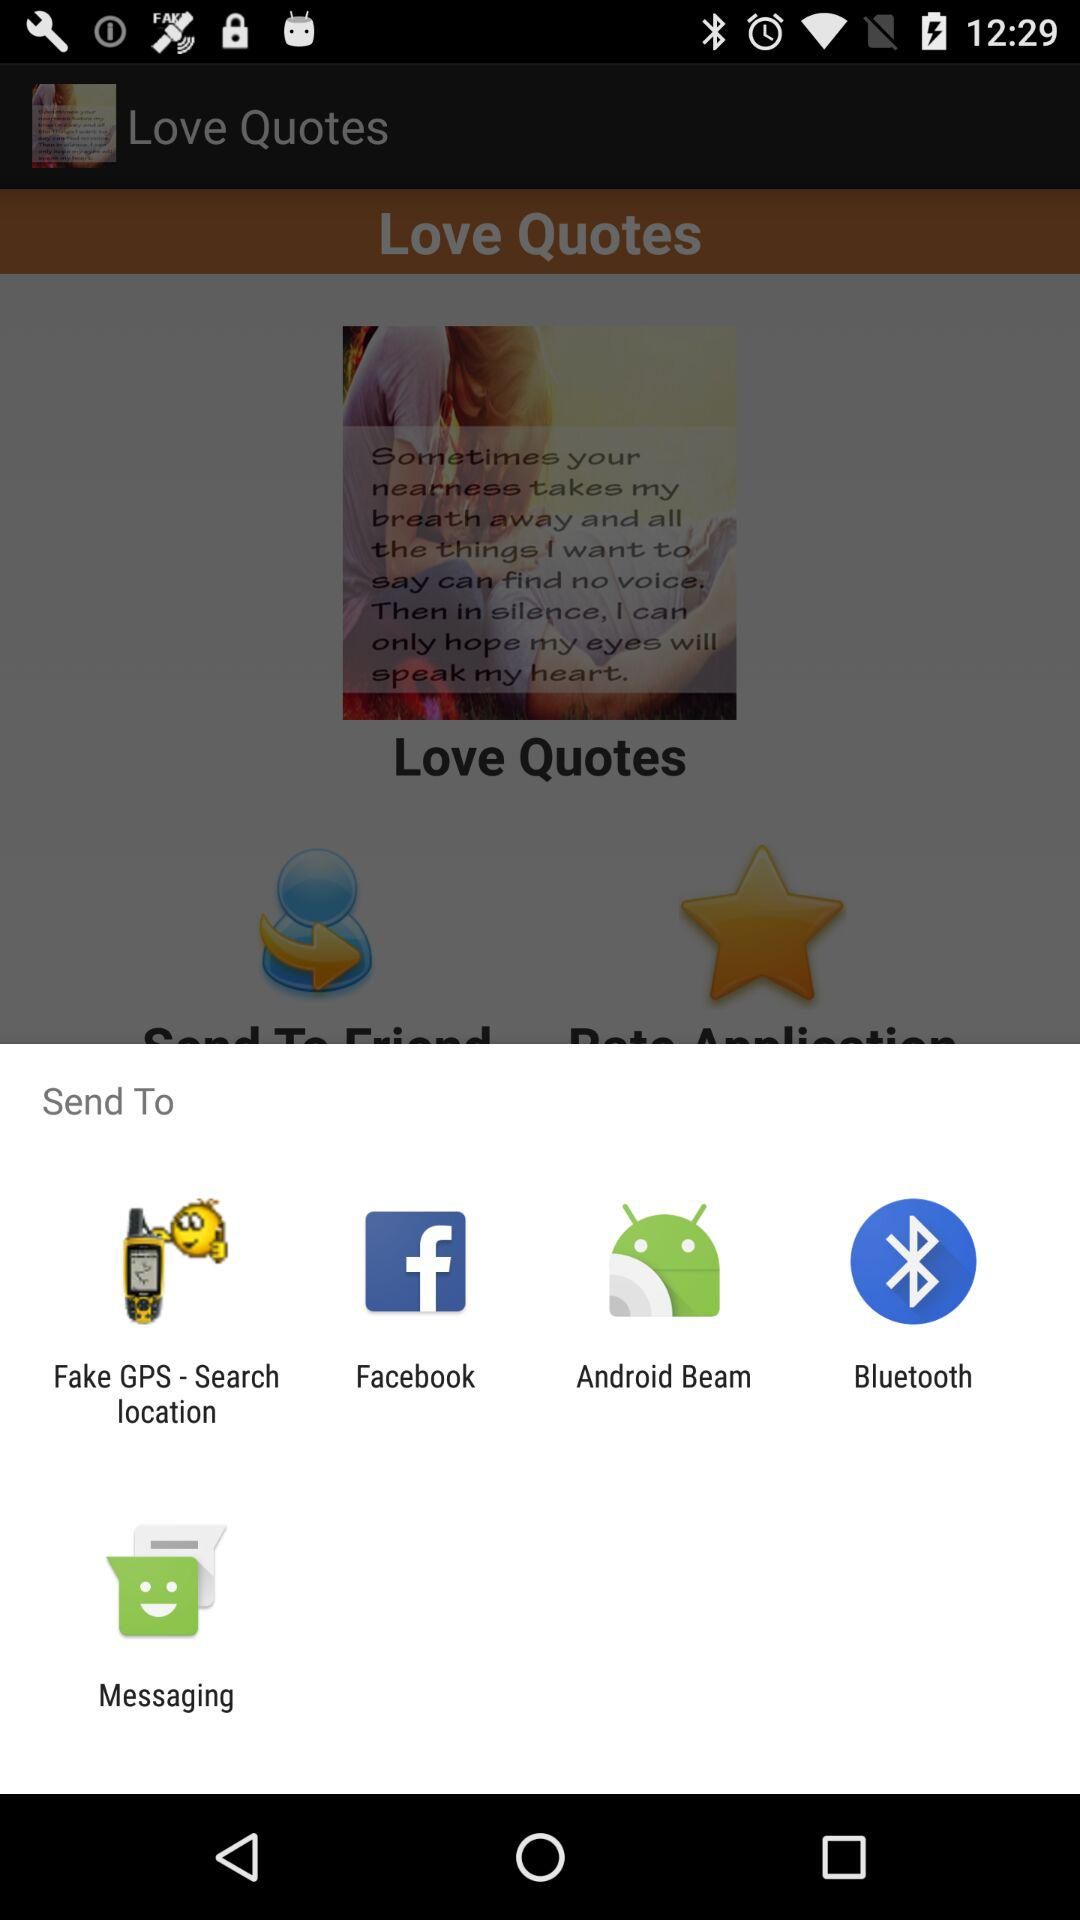To which application can we send the content? You can send the content to "Fake GPS - Search location", "Facebook", "Android Beam", "Bluetooth" and "Messaging". 